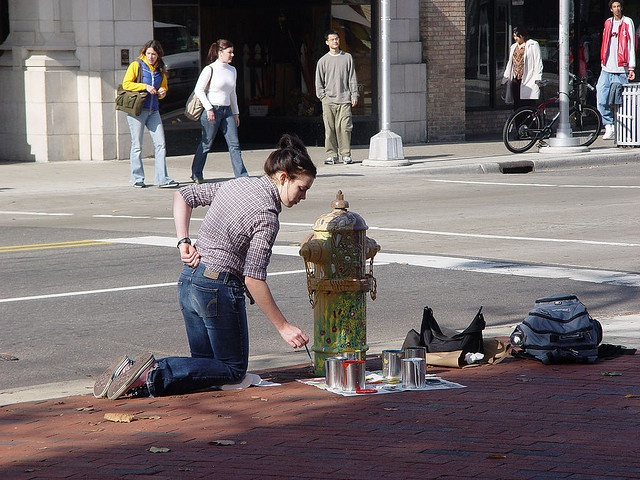Describe the objects in this image and their specific colors. I can see people in black, darkgray, lightgray, and gray tones, fire hydrant in black, darkgreen, gray, and maroon tones, backpack in black, gray, navy, and darkblue tones, people in black, white, darkgray, and gray tones, and people in black, darkgray, gray, and lightgray tones in this image. 